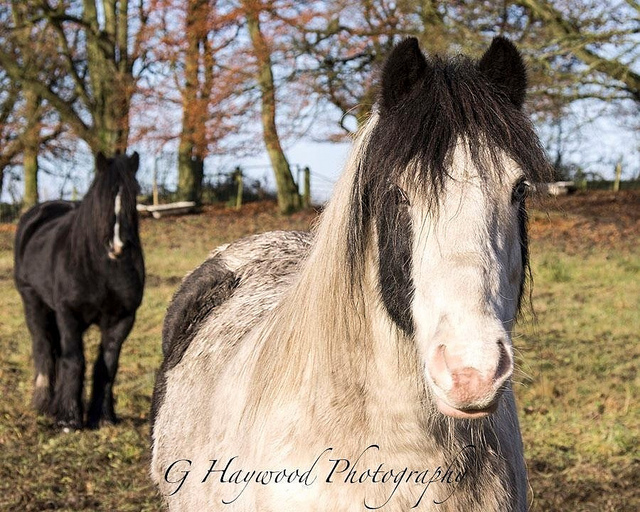Please transcribe the text in this image. G Haya Photography 